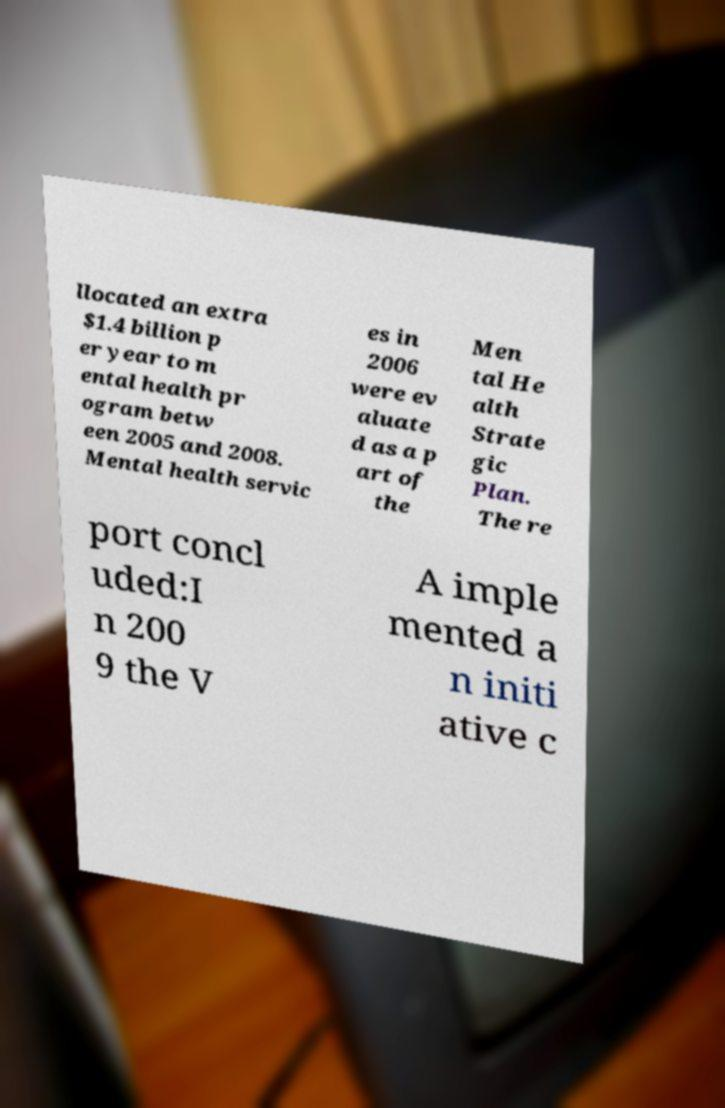There's text embedded in this image that I need extracted. Can you transcribe it verbatim? llocated an extra $1.4 billion p er year to m ental health pr ogram betw een 2005 and 2008. Mental health servic es in 2006 were ev aluate d as a p art of the Men tal He alth Strate gic Plan. The re port concl uded:I n 200 9 the V A imple mented a n initi ative c 